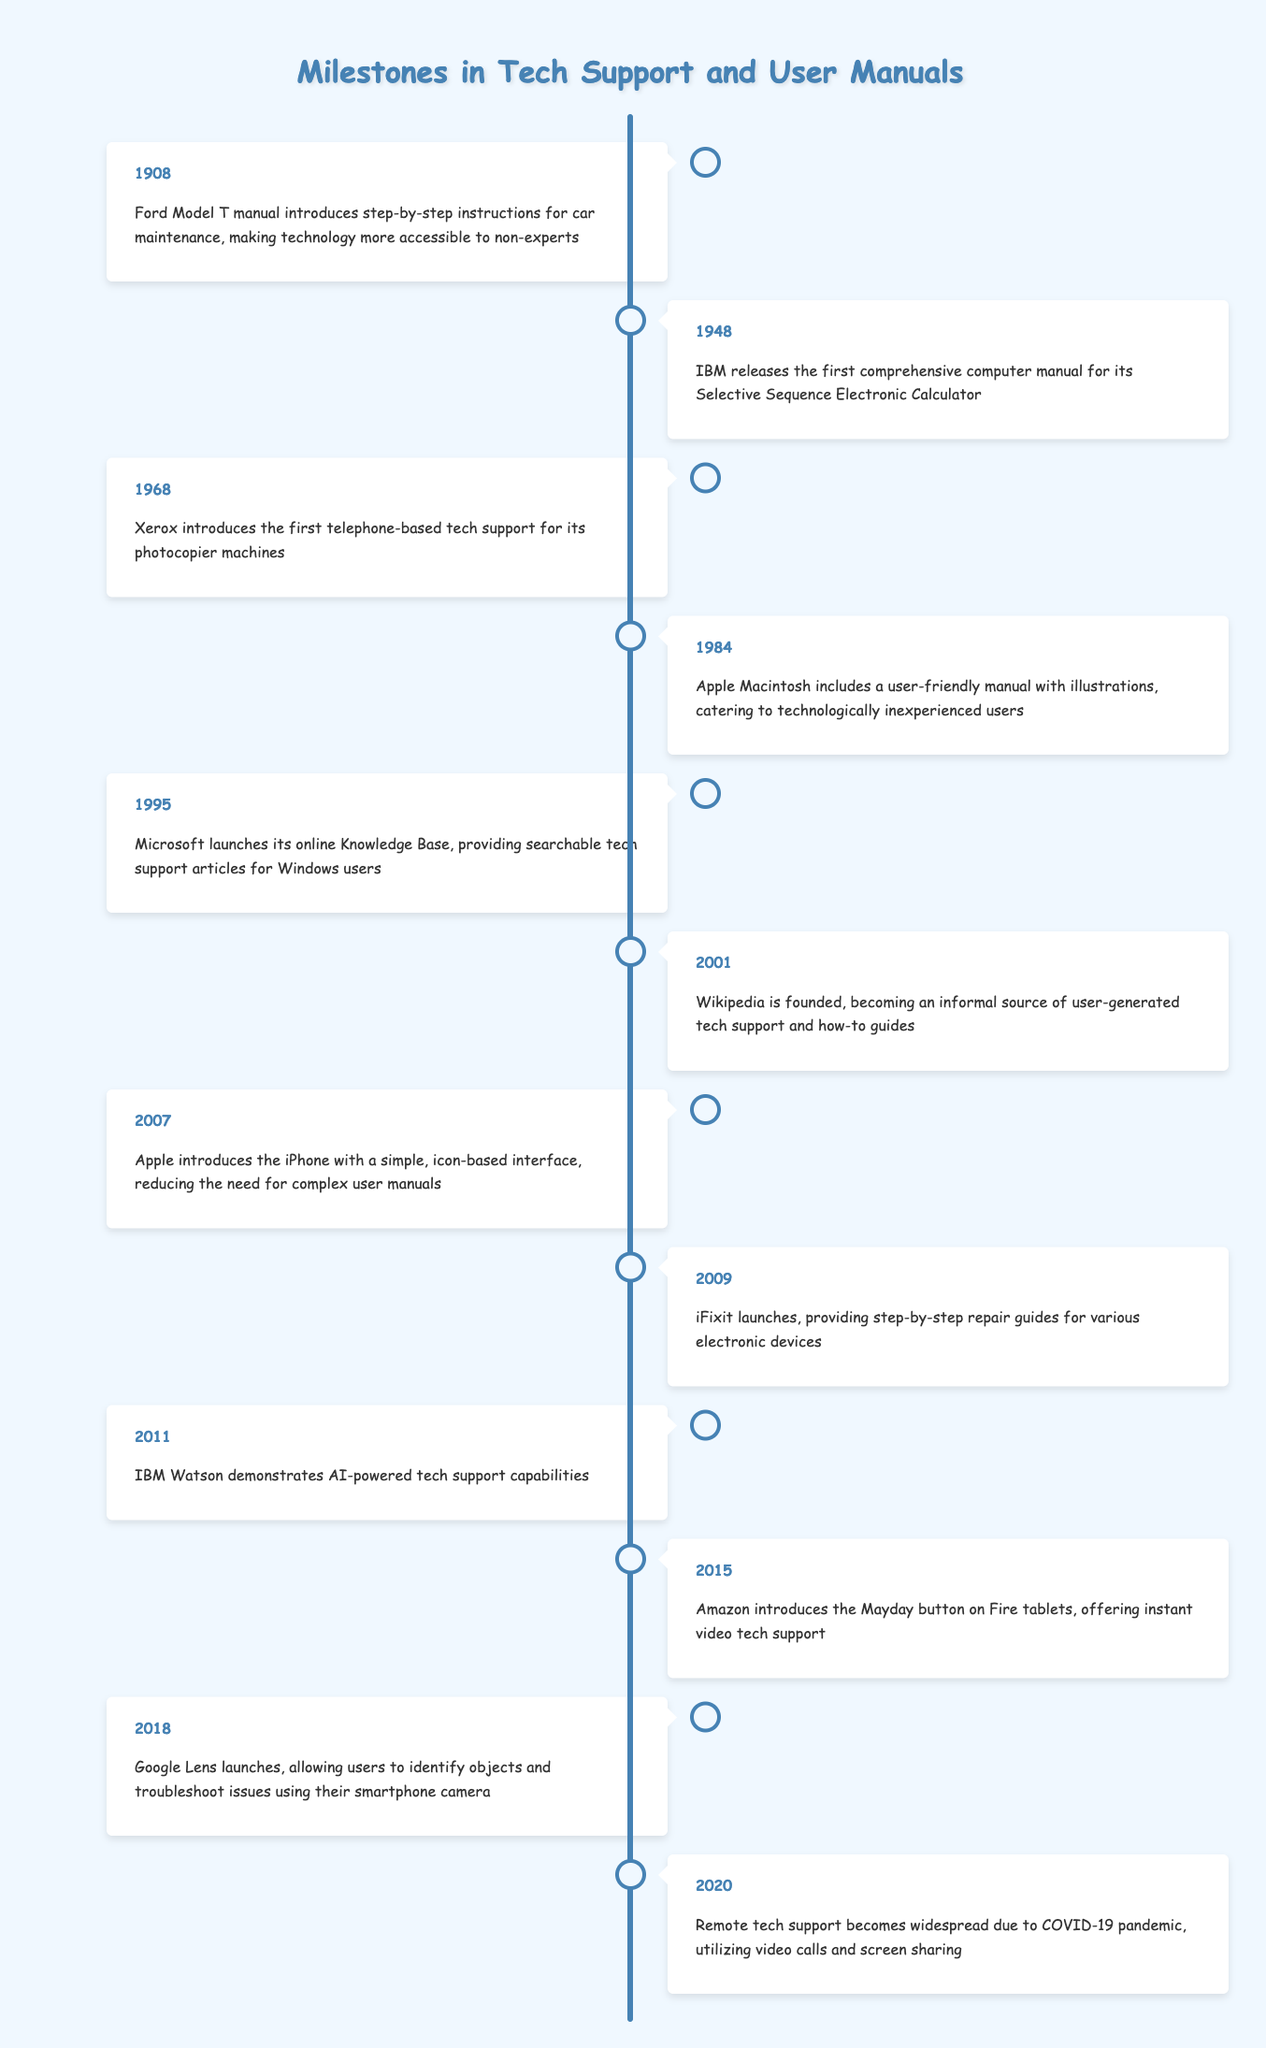What milestone in tech support happened in 1968? The timeline shows that in 1968, Xerox introduced the first telephone-based tech support for its photocopier machines.
Answer: Xerox introduced telephone-based tech support in 1968 Which year saw the launch of Microsoft's online Knowledge Base? According to the timeline, Microsoft's online Knowledge Base was launched in 1995.
Answer: 1995 How many significant milestones were recorded before the year 2000? Inspecting the timeline, there are 7 milestones (1908, 1948, 1968, 1984, 1995, 2001) before the year 2000.
Answer: 7 Is it true that the Apple iPhone introduced a complex user manual? The timeline indicates that the Apple iPhone, introduced in 2007, had a simple, icon-based interface, reducing the need for complex user manuals. Therefore, the statement is false.
Answer: False Which milestone reflects a shift towards using artificial intelligence in tech support? The timeline highlights that in 2011, IBM Watson demonstrated AI-powered tech support capabilities, indicating a significant shift towards using artificial intelligence.
Answer: IBM Watson in 2011 What is the average gap in years between the milestones listed from 1908 to 2020? First, calculate the total span of years: 2020 - 1908 = 112 years. Next, count the number of milestones: there are 12. The average gap is 112 years divided by 11 gaps (12 milestones - 1) = approximately 10.18 years.
Answer: Approximately 10.18 years After 2010, how many advancements were focused on immediate tech support? Looking at the timeline, there are 4 milestones after 2010 focused on immediate tech support: 2011 (IBM Watson), 2015 (Amazon Mayday button), 2018 (Google Lens), and 2020 (Remote tech support).
Answer: 4 advancements Which event introduced a major change in how users could repair their devices? The timeline shows that in 2009, iFixit launched, providing step-by-step repair guides, marking a major change in how users could repair their devices.
Answer: iFixit in 2009 What significant change to user manuals occurred with the introduction of the Apple Macintosh? In 1984, the Apple Macintosh included a user-friendly manual with illustrations, which catered to technologically inexperienced users, marking a significant improvement in user manuals.
Answer: User-friendly manual for Apple Macintosh in 1984 